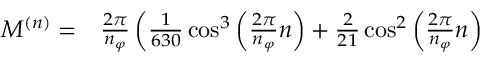Convert formula to latex. <formula><loc_0><loc_0><loc_500><loc_500>\begin{array} { r l } { M ^ { ( n ) } = } & \frac { 2 \pi } { n _ { \varphi } } \left ( \frac { 1 } { 6 3 0 } \cos ^ { 3 } \left ( \frac { 2 \pi } { n _ { \varphi } } n \right ) + \frac { 2 } { 2 1 } \cos ^ { 2 } \left ( \frac { 2 \pi } { n _ { \varphi } } n \right ) } \end{array}</formula> 